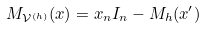Convert formula to latex. <formula><loc_0><loc_0><loc_500><loc_500>M _ { \mathcal { V } ^ { ( h ) } } ( x ) = x _ { n } I _ { n } - M _ { h } ( x ^ { \prime } )</formula> 